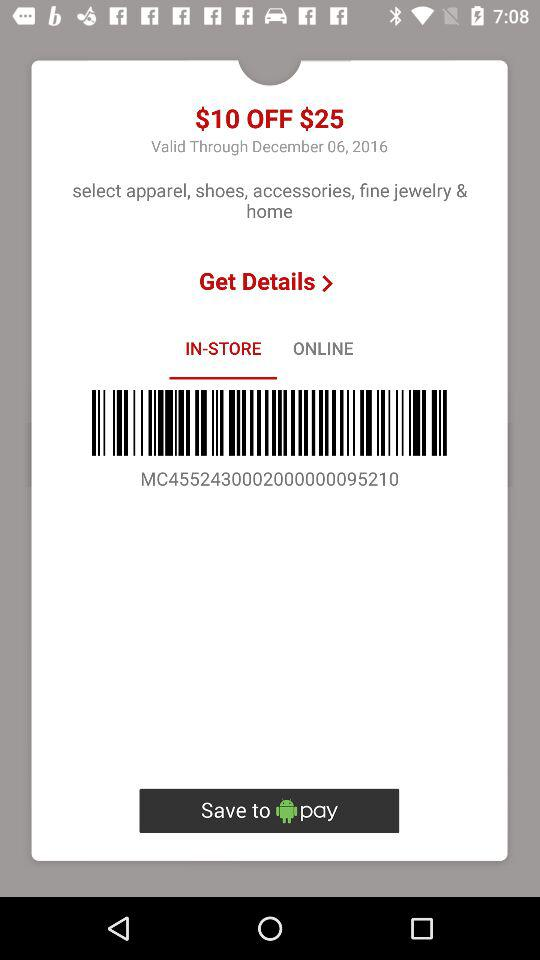How much do I need to spend to use this coupon?
Answer the question using a single word or phrase. $25 